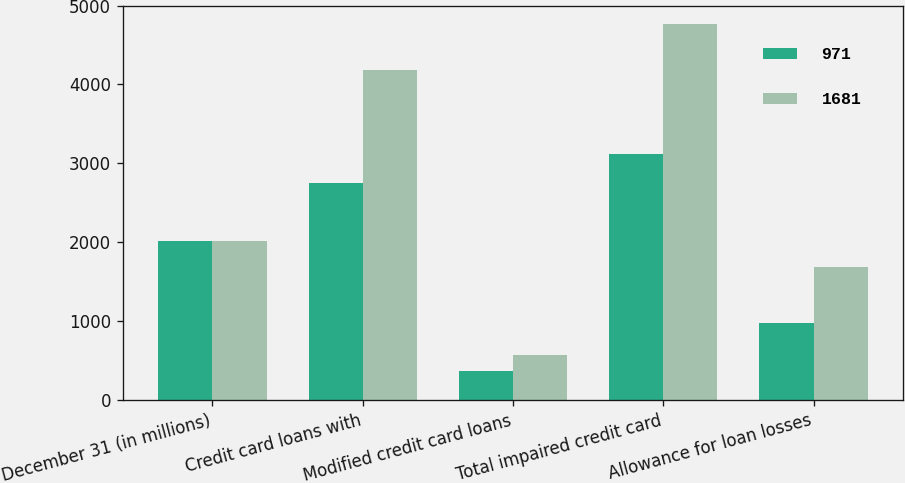<chart> <loc_0><loc_0><loc_500><loc_500><stacked_bar_chart><ecel><fcel>December 31 (in millions)<fcel>Credit card loans with<fcel>Modified credit card loans<fcel>Total impaired credit card<fcel>Allowance for loan losses<nl><fcel>971<fcel>2013<fcel>2746<fcel>369<fcel>3115<fcel>971<nl><fcel>1681<fcel>2012<fcel>4189<fcel>573<fcel>4762<fcel>1681<nl></chart> 